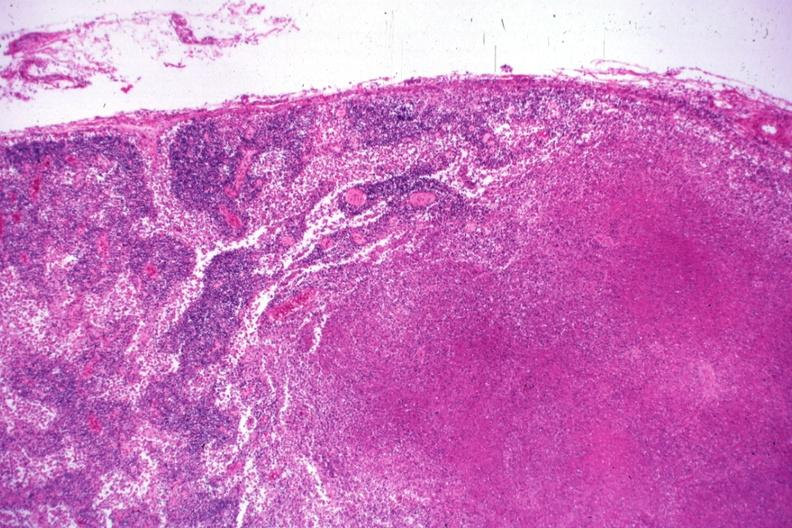what is present?
Answer the question using a single word or phrase. Tuberculosis 